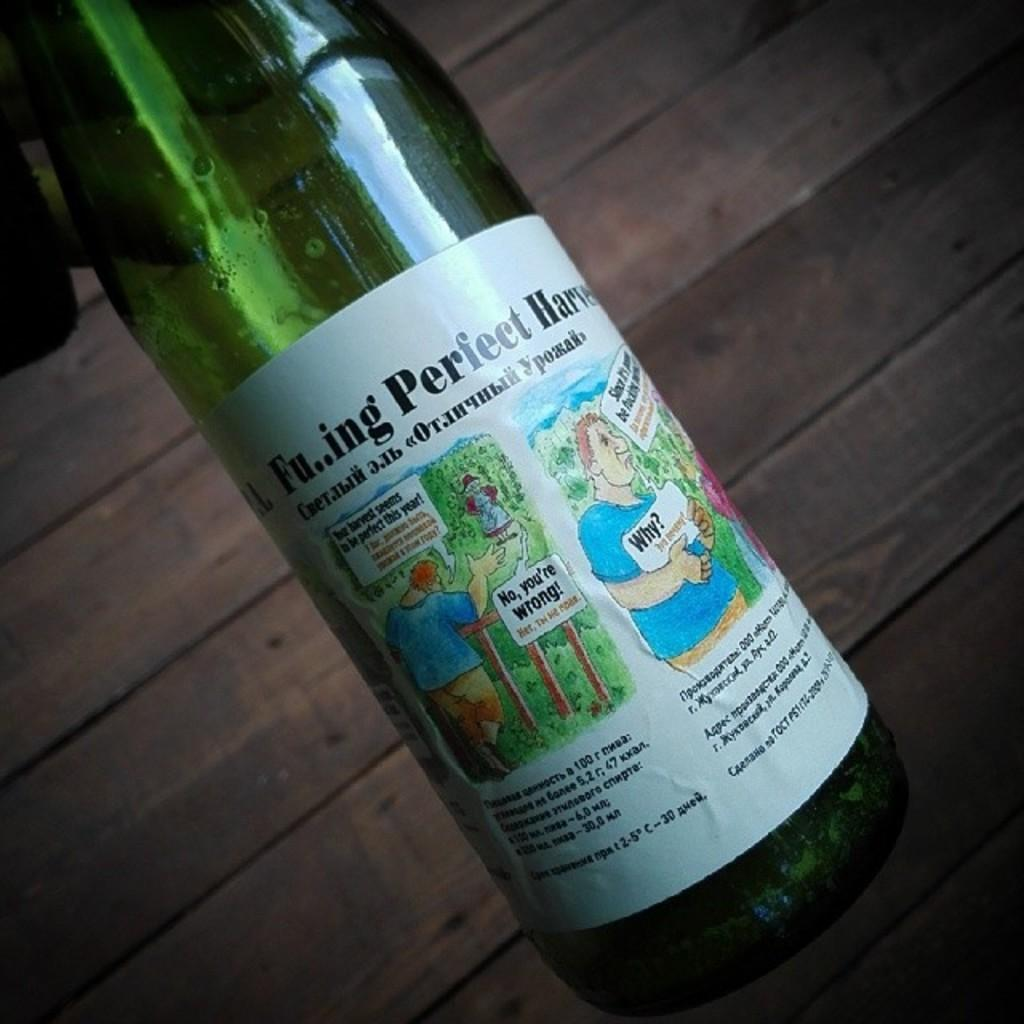<image>
Relay a brief, clear account of the picture shown. A beverage bottle has a cartoon man holding a sign that says Why? on it. 